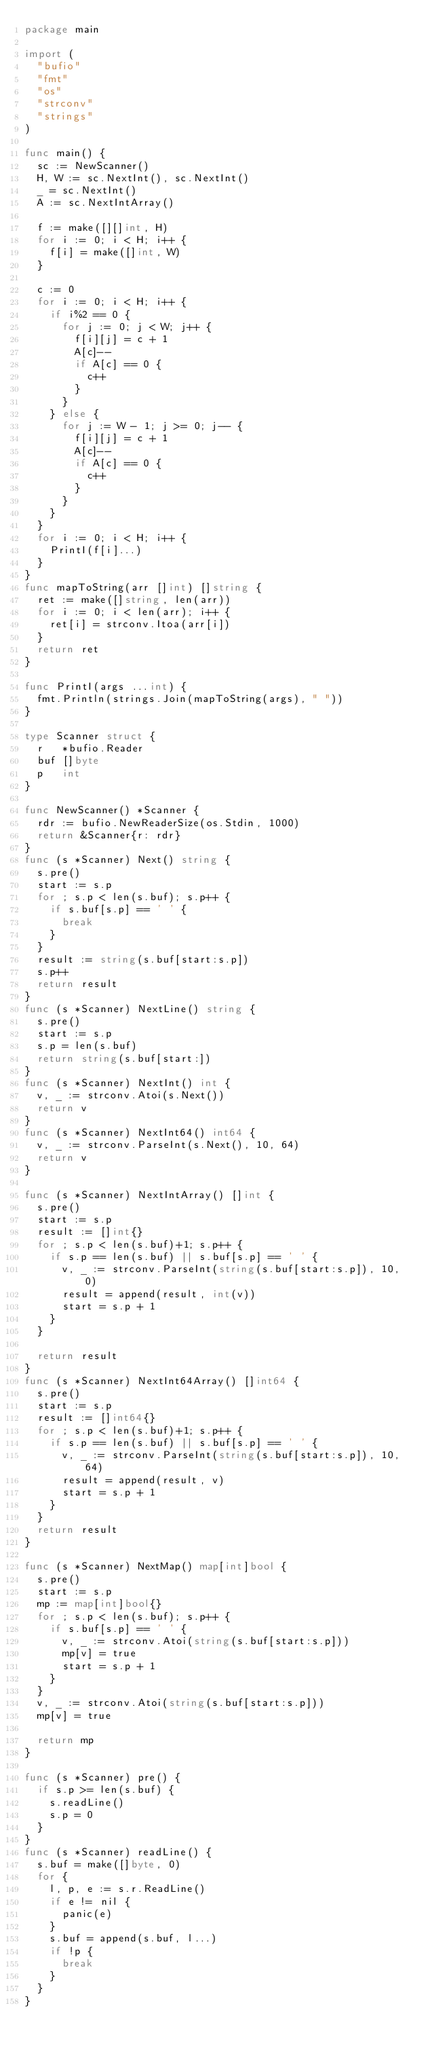<code> <loc_0><loc_0><loc_500><loc_500><_Go_>package main

import (
	"bufio"
	"fmt"
	"os"
	"strconv"
	"strings"
)

func main() {
	sc := NewScanner()
	H, W := sc.NextInt(), sc.NextInt()
	_ = sc.NextInt()
	A := sc.NextIntArray()

	f := make([][]int, H)
	for i := 0; i < H; i++ {
		f[i] = make([]int, W)
	}

	c := 0
	for i := 0; i < H; i++ {
		if i%2 == 0 {
			for j := 0; j < W; j++ {
				f[i][j] = c + 1
				A[c]--
				if A[c] == 0 {
					c++
				}
			}
		} else {
			for j := W - 1; j >= 0; j-- {
				f[i][j] = c + 1
				A[c]--
				if A[c] == 0 {
					c++
				}
			}
		}
	}
	for i := 0; i < H; i++ {
		PrintI(f[i]...)
	}
}
func mapToString(arr []int) []string {
	ret := make([]string, len(arr))
	for i := 0; i < len(arr); i++ {
		ret[i] = strconv.Itoa(arr[i])
	}
	return ret
}

func PrintI(args ...int) {
	fmt.Println(strings.Join(mapToString(args), " "))
}

type Scanner struct {
	r   *bufio.Reader
	buf []byte
	p   int
}

func NewScanner() *Scanner {
	rdr := bufio.NewReaderSize(os.Stdin, 1000)
	return &Scanner{r: rdr}
}
func (s *Scanner) Next() string {
	s.pre()
	start := s.p
	for ; s.p < len(s.buf); s.p++ {
		if s.buf[s.p] == ' ' {
			break
		}
	}
	result := string(s.buf[start:s.p])
	s.p++
	return result
}
func (s *Scanner) NextLine() string {
	s.pre()
	start := s.p
	s.p = len(s.buf)
	return string(s.buf[start:])
}
func (s *Scanner) NextInt() int {
	v, _ := strconv.Atoi(s.Next())
	return v
}
func (s *Scanner) NextInt64() int64 {
	v, _ := strconv.ParseInt(s.Next(), 10, 64)
	return v
}

func (s *Scanner) NextIntArray() []int {
	s.pre()
	start := s.p
	result := []int{}
	for ; s.p < len(s.buf)+1; s.p++ {
		if s.p == len(s.buf) || s.buf[s.p] == ' ' {
			v, _ := strconv.ParseInt(string(s.buf[start:s.p]), 10, 0)
			result = append(result, int(v))
			start = s.p + 1
		}
	}

	return result
}
func (s *Scanner) NextInt64Array() []int64 {
	s.pre()
	start := s.p
	result := []int64{}
	for ; s.p < len(s.buf)+1; s.p++ {
		if s.p == len(s.buf) || s.buf[s.p] == ' ' {
			v, _ := strconv.ParseInt(string(s.buf[start:s.p]), 10, 64)
			result = append(result, v)
			start = s.p + 1
		}
	}
	return result
}

func (s *Scanner) NextMap() map[int]bool {
	s.pre()
	start := s.p
	mp := map[int]bool{}
	for ; s.p < len(s.buf); s.p++ {
		if s.buf[s.p] == ' ' {
			v, _ := strconv.Atoi(string(s.buf[start:s.p]))
			mp[v] = true
			start = s.p + 1
		}
	}
	v, _ := strconv.Atoi(string(s.buf[start:s.p]))
	mp[v] = true

	return mp
}

func (s *Scanner) pre() {
	if s.p >= len(s.buf) {
		s.readLine()
		s.p = 0
	}
}
func (s *Scanner) readLine() {
	s.buf = make([]byte, 0)
	for {
		l, p, e := s.r.ReadLine()
		if e != nil {
			panic(e)
		}
		s.buf = append(s.buf, l...)
		if !p {
			break
		}
	}
}
</code> 